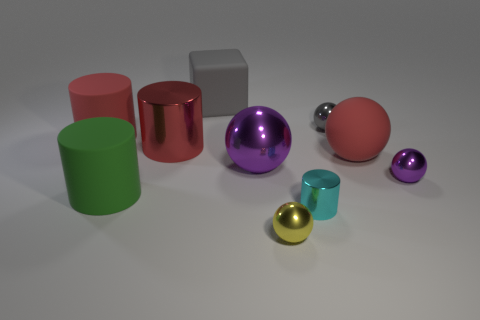Subtract all big shiny spheres. How many spheres are left? 4 Subtract all gray blocks. How many red cylinders are left? 2 Subtract all cubes. How many objects are left? 9 Subtract 3 spheres. How many spheres are left? 2 Subtract all red spheres. How many spheres are left? 4 Subtract 1 cyan cylinders. How many objects are left? 9 Subtract all green balls. Subtract all gray blocks. How many balls are left? 5 Subtract all large blue metallic cylinders. Subtract all small metallic things. How many objects are left? 6 Add 9 gray rubber objects. How many gray rubber objects are left? 10 Add 5 large green objects. How many large green objects exist? 6 